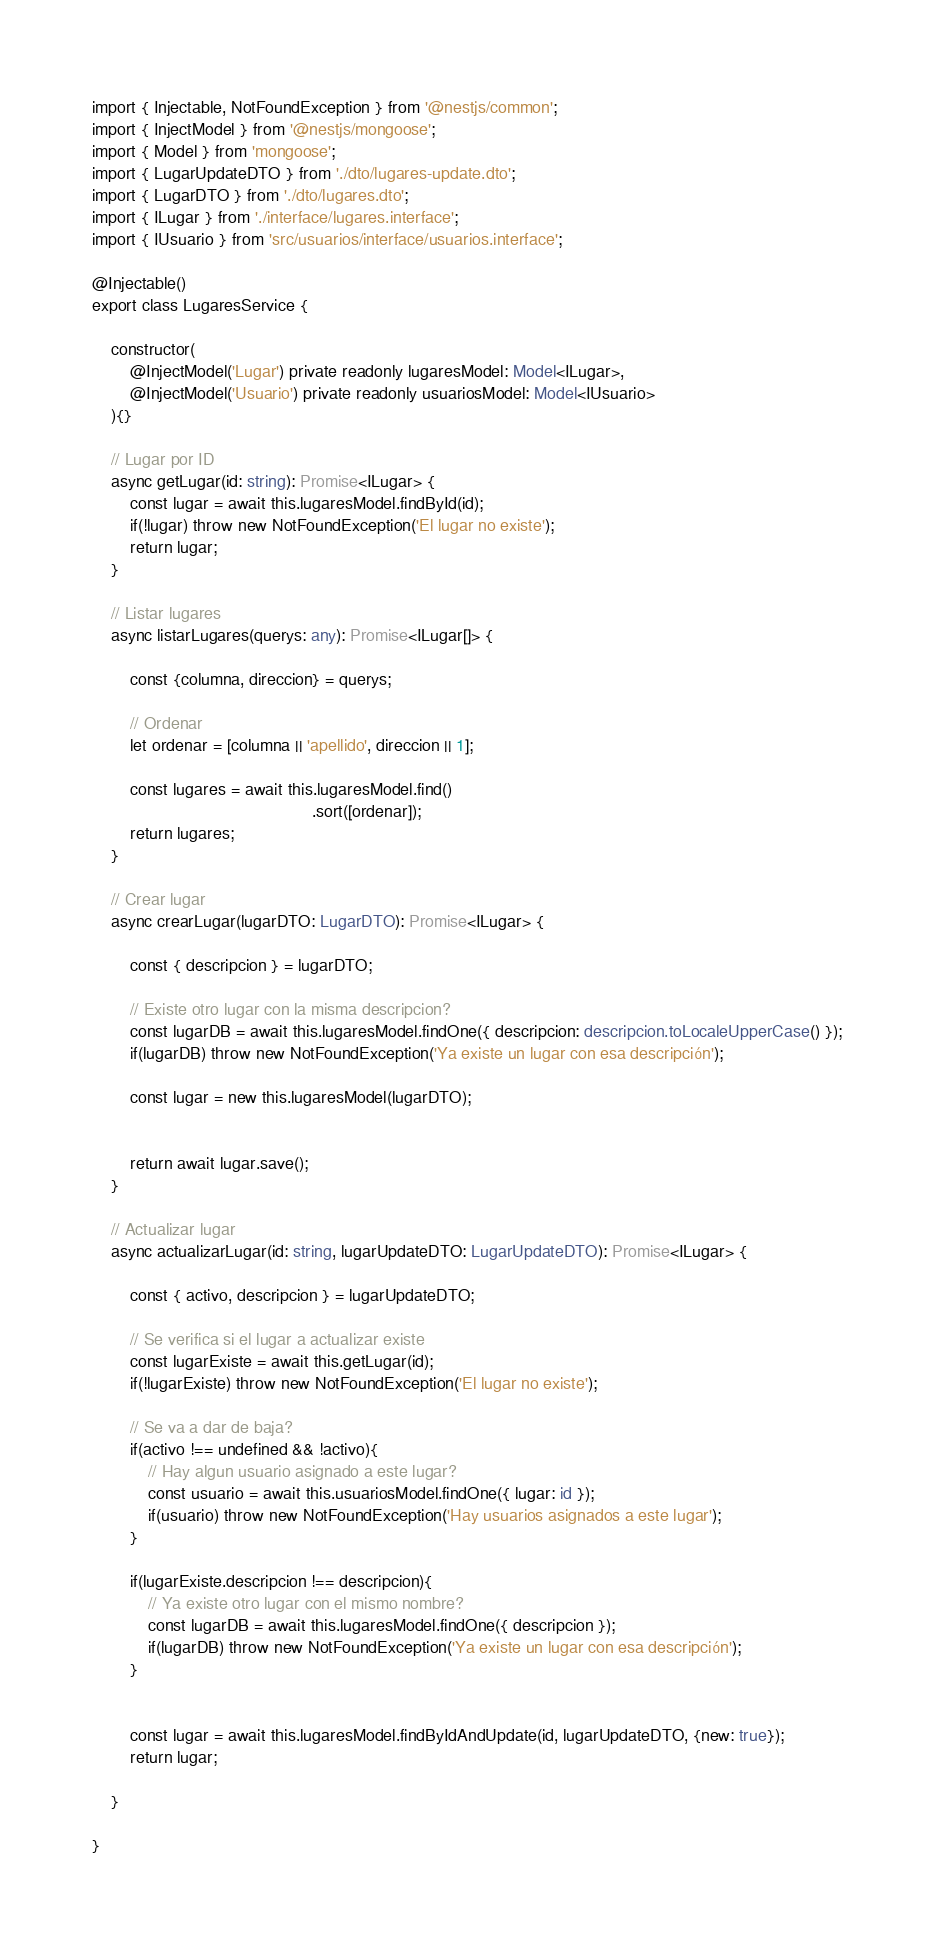<code> <loc_0><loc_0><loc_500><loc_500><_TypeScript_>import { Injectable, NotFoundException } from '@nestjs/common';
import { InjectModel } from '@nestjs/mongoose';
import { Model } from 'mongoose';
import { LugarUpdateDTO } from './dto/lugares-update.dto';
import { LugarDTO } from './dto/lugares.dto';
import { ILugar } from './interface/lugares.interface';
import { IUsuario } from 'src/usuarios/interface/usuarios.interface';

@Injectable()
export class LugaresService {

    constructor(
        @InjectModel('Lugar') private readonly lugaresModel: Model<ILugar>,
        @InjectModel('Usuario') private readonly usuariosModel: Model<IUsuario>    
    ){}

    // Lugar por ID
    async getLugar(id: string): Promise<ILugar> {
        const lugar = await this.lugaresModel.findById(id);
        if(!lugar) throw new NotFoundException('El lugar no existe');
        return lugar;
    }  
    
    // Listar lugares
    async listarLugares(querys: any): Promise<ILugar[]> {
        
        const {columna, direccion} = querys;

        // Ordenar
        let ordenar = [columna || 'apellido', direccion || 1];
        
        const lugares = await this.lugaresModel.find()
                                               .sort([ordenar]);
        return lugares;
    }  

    // Crear lugar
    async crearLugar(lugarDTO: LugarDTO): Promise<ILugar> {
        
        const { descripcion } = lugarDTO;

        // Existe otro lugar con la misma descripcion?
        const lugarDB = await this.lugaresModel.findOne({ descripcion: descripcion.toLocaleUpperCase() });
        if(lugarDB) throw new NotFoundException('Ya existe un lugar con esa descripción');
        
        const lugar = new this.lugaresModel(lugarDTO);


        return await lugar.save();
    }

    // Actualizar lugar
    async actualizarLugar(id: string, lugarUpdateDTO: LugarUpdateDTO): Promise<ILugar> {
       
        const { activo, descripcion } = lugarUpdateDTO;

        // Se verifica si el lugar a actualizar existe
        const lugarExiste = await this.getLugar(id);
        if(!lugarExiste) throw new NotFoundException('El lugar no existe');
        
        // Se va a dar de baja?
        if(activo !== undefined && !activo){
            // Hay algun usuario asignado a este lugar?
            const usuario = await this.usuariosModel.findOne({ lugar: id });
            if(usuario) throw new NotFoundException('Hay usuarios asignados a este lugar');
        }
        
        if(lugarExiste.descripcion !== descripcion){
            // Ya existe otro lugar con el mismo nombre?
            const lugarDB = await this.lugaresModel.findOne({ descripcion });
            if(lugarDB) throw new NotFoundException('Ya existe un lugar con esa descripción');
        }
        

        const lugar = await this.lugaresModel.findByIdAndUpdate(id, lugarUpdateDTO, {new: true});
        return lugar;
    
    }
      
}
</code> 